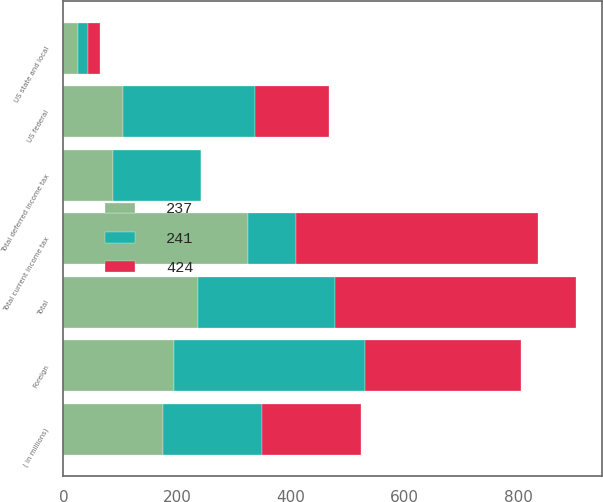Convert chart to OTSL. <chart><loc_0><loc_0><loc_500><loc_500><stacked_bar_chart><ecel><fcel>( in millions)<fcel>US federal<fcel>US state and local<fcel>Foreign<fcel>Total current income tax<fcel>Total deferred income tax<fcel>Total<nl><fcel>241<fcel>174.5<fcel>232<fcel>19<fcel>337<fcel>86<fcel>155<fcel>241<nl><fcel>424<fcel>174.5<fcel>130<fcel>20<fcel>275<fcel>425<fcel>1<fcel>424<nl><fcel>237<fcel>174.5<fcel>105<fcel>25<fcel>194<fcel>324<fcel>87<fcel>237<nl></chart> 